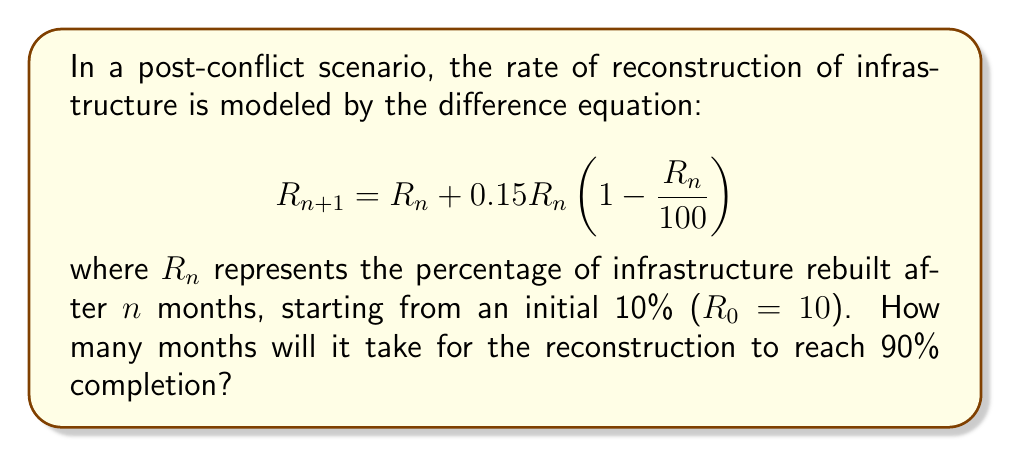Teach me how to tackle this problem. To solve this problem, we need to iterate the difference equation until we reach or exceed 90% reconstruction. Let's follow these steps:

1) Start with $R_0 = 10$

2) Calculate successive values of $R_n$ using the equation:
   $$R_{n+1} = R_n + 0.15R_n(1 - \frac{R_n}{100})$$

3) Continue until $R_n \geq 90$

Let's calculate:

Month 0: $R_0 = 10$

Month 1: $R_1 = 10 + 0.15 \cdot 10 \cdot (1 - \frac{10}{100}) = 11.35$

Month 2: $R_2 = 11.35 + 0.15 \cdot 11.35 \cdot (1 - \frac{11.35}{100}) = 12.89$

Month 3: $R_3 = 14.60$

Month 4: $R_4 = 16.49$

...

Month 20: $R_{20} = 86.37$

Month 21: $R_{21} = 89.95$

Month 22: $R_{22} = 92.91$

We see that after 22 months, the reconstruction percentage exceeds 90%.
Answer: 22 months 